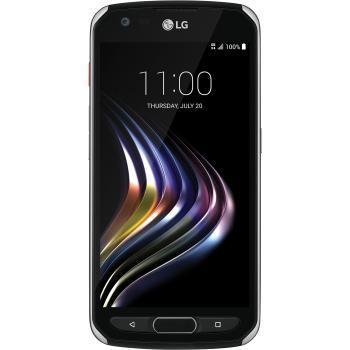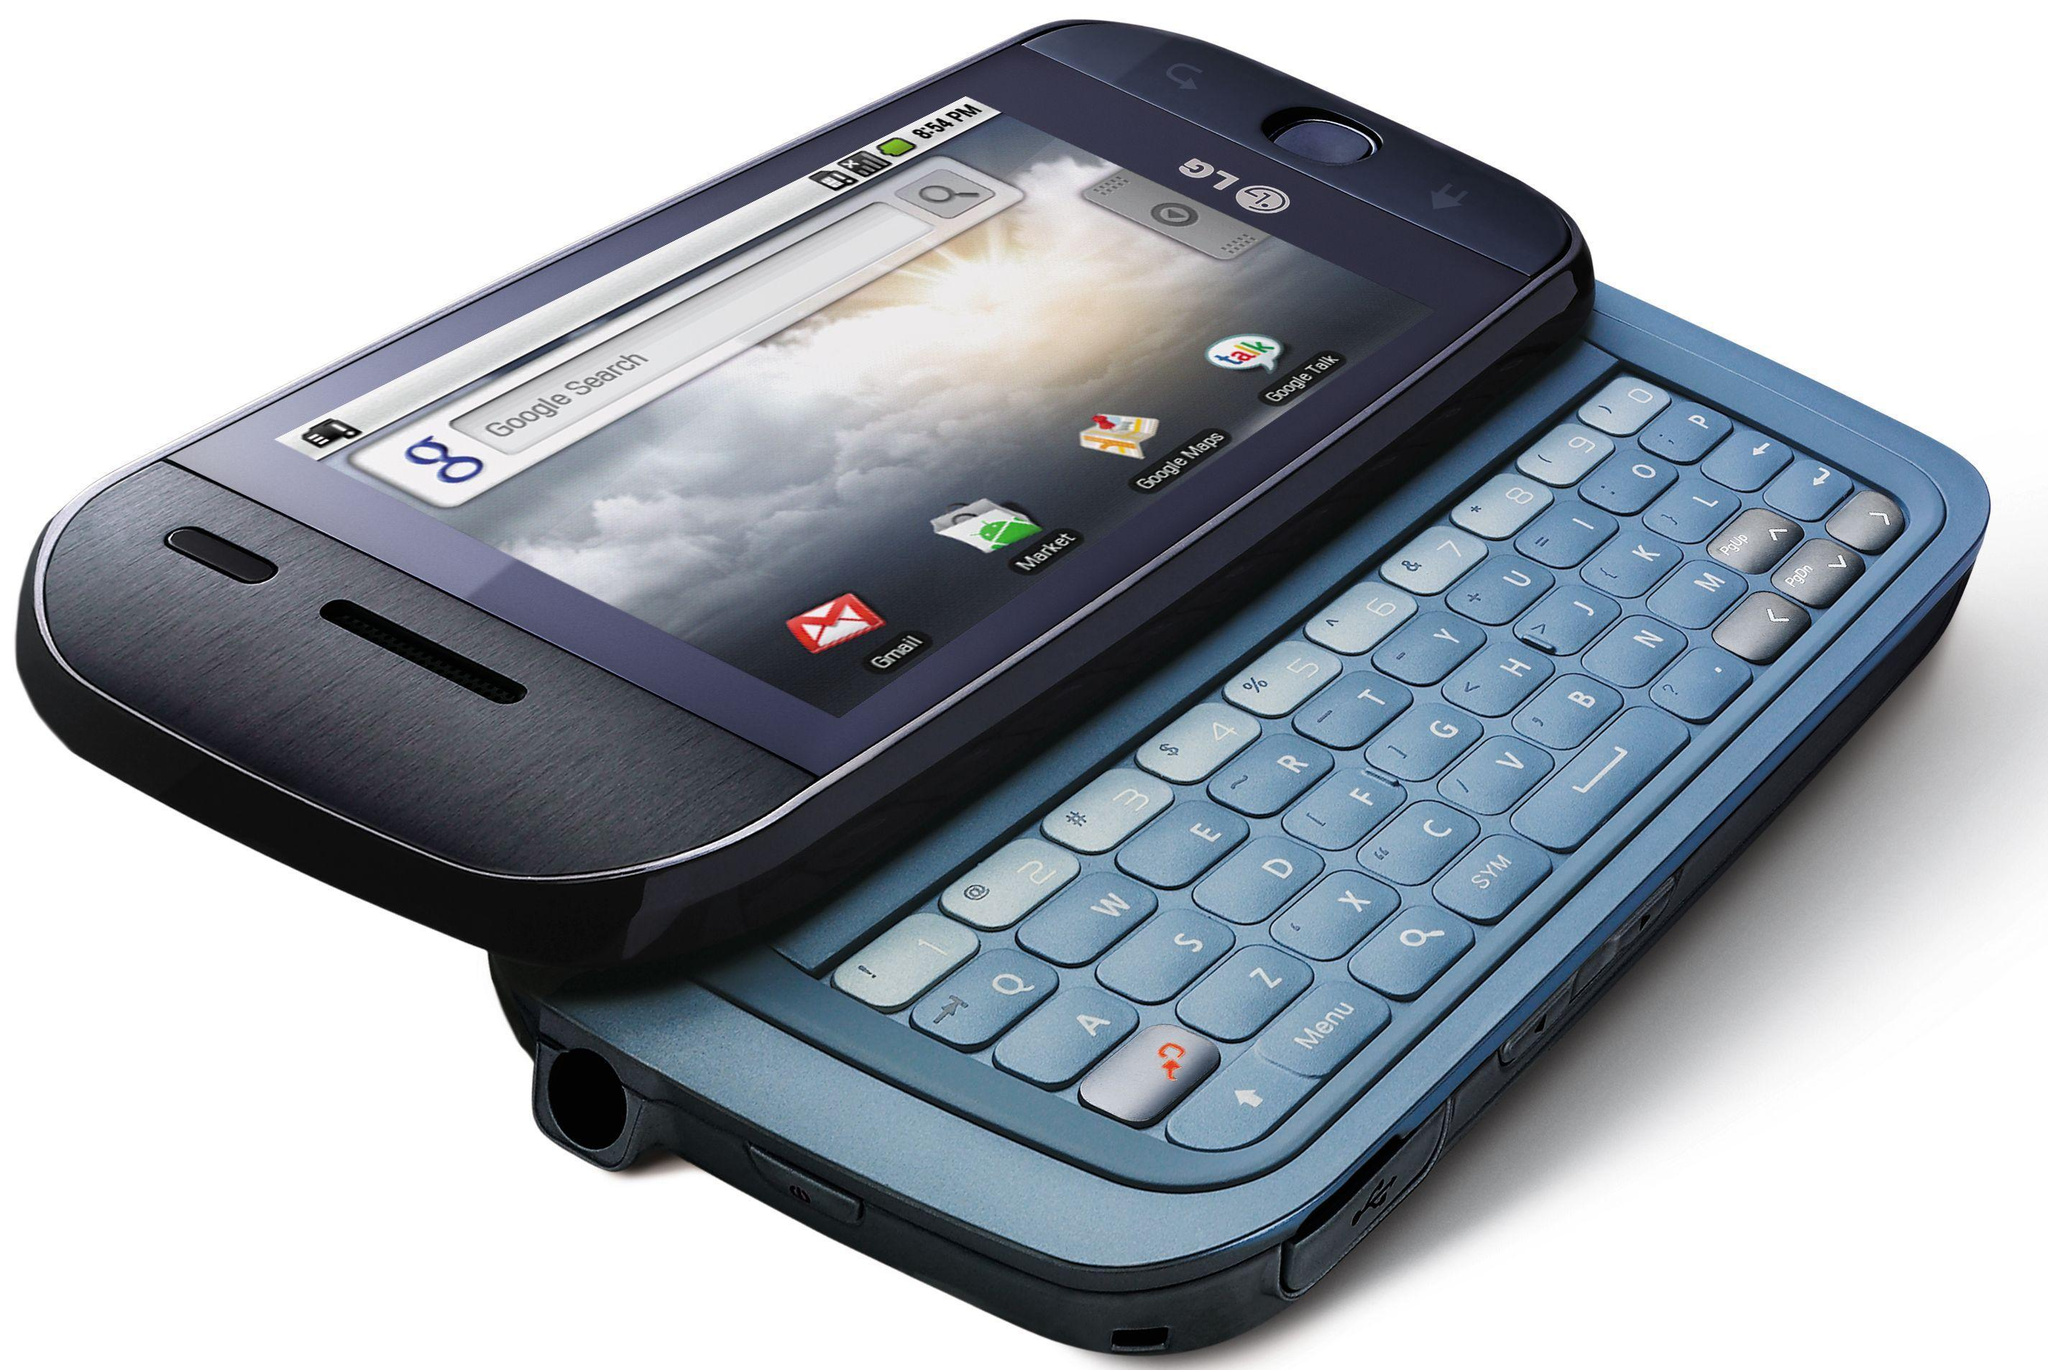The first image is the image on the left, the second image is the image on the right. Given the left and right images, does the statement "One of the phones has keys that slide out from under the screen." hold true? Answer yes or no. Yes. The first image is the image on the left, the second image is the image on the right. For the images shown, is this caption "There is one modern touchscreen smartphone and one older cell phone with buttons." true? Answer yes or no. Yes. 